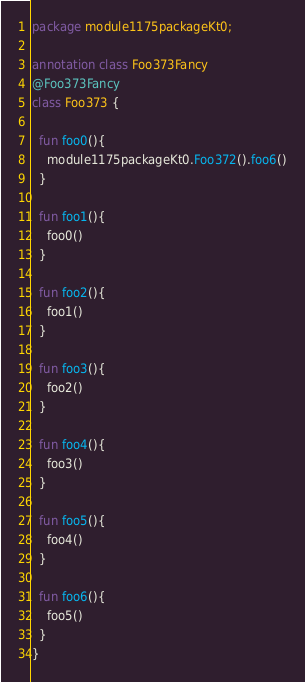Convert code to text. <code><loc_0><loc_0><loc_500><loc_500><_Kotlin_>package module1175packageKt0;

annotation class Foo373Fancy
@Foo373Fancy
class Foo373 {

  fun foo0(){
    module1175packageKt0.Foo372().foo6()
  }

  fun foo1(){
    foo0()
  }

  fun foo2(){
    foo1()
  }

  fun foo3(){
    foo2()
  }

  fun foo4(){
    foo3()
  }

  fun foo5(){
    foo4()
  }

  fun foo6(){
    foo5()
  }
}</code> 